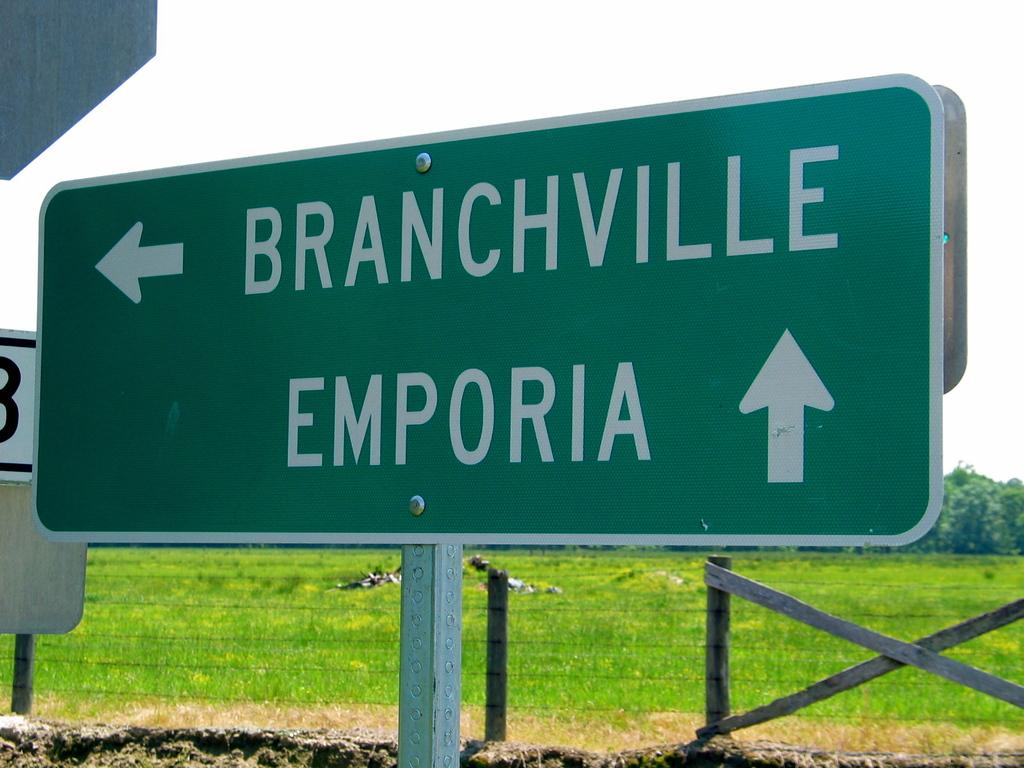<image>
Create a compact narrative representing the image presented. A street sign show that Emporia is ahead. 